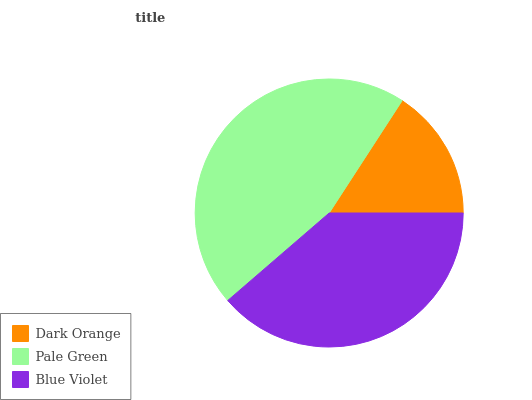Is Dark Orange the minimum?
Answer yes or no. Yes. Is Pale Green the maximum?
Answer yes or no. Yes. Is Blue Violet the minimum?
Answer yes or no. No. Is Blue Violet the maximum?
Answer yes or no. No. Is Pale Green greater than Blue Violet?
Answer yes or no. Yes. Is Blue Violet less than Pale Green?
Answer yes or no. Yes. Is Blue Violet greater than Pale Green?
Answer yes or no. No. Is Pale Green less than Blue Violet?
Answer yes or no. No. Is Blue Violet the high median?
Answer yes or no. Yes. Is Blue Violet the low median?
Answer yes or no. Yes. Is Dark Orange the high median?
Answer yes or no. No. Is Pale Green the low median?
Answer yes or no. No. 